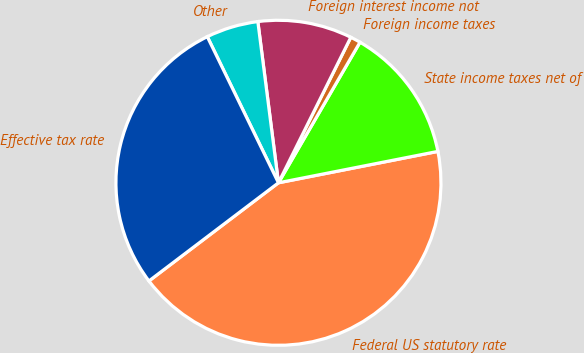Convert chart. <chart><loc_0><loc_0><loc_500><loc_500><pie_chart><fcel>Federal US statutory rate<fcel>State income taxes net of<fcel>Foreign income taxes<fcel>Foreign interest income not<fcel>Other<fcel>Effective tax rate<nl><fcel>42.77%<fcel>13.54%<fcel>1.02%<fcel>9.37%<fcel>5.19%<fcel>28.11%<nl></chart> 